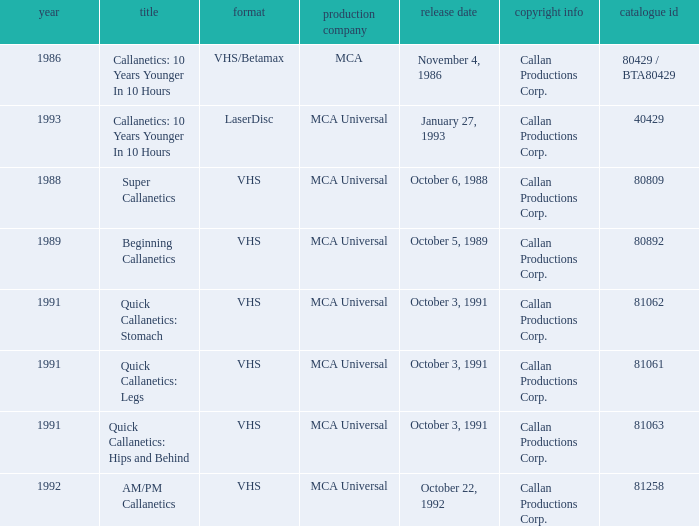Name the catalog number for am/pm callanetics 81258.0. Write the full table. {'header': ['year', 'title', 'format', 'production company', 'release date', 'copyright info', 'catalogue id'], 'rows': [['1986', 'Callanetics: 10 Years Younger In 10 Hours', 'VHS/Betamax', 'MCA', 'November 4, 1986', 'Callan Productions Corp.', '80429 / BTA80429'], ['1993', 'Callanetics: 10 Years Younger In 10 Hours', 'LaserDisc', 'MCA Universal', 'January 27, 1993', 'Callan Productions Corp.', '40429'], ['1988', 'Super Callanetics', 'VHS', 'MCA Universal', 'October 6, 1988', 'Callan Productions Corp.', '80809'], ['1989', 'Beginning Callanetics', 'VHS', 'MCA Universal', 'October 5, 1989', 'Callan Productions Corp.', '80892'], ['1991', 'Quick Callanetics: Stomach', 'VHS', 'MCA Universal', 'October 3, 1991', 'Callan Productions Corp.', '81062'], ['1991', 'Quick Callanetics: Legs', 'VHS', 'MCA Universal', 'October 3, 1991', 'Callan Productions Corp.', '81061'], ['1991', 'Quick Callanetics: Hips and Behind', 'VHS', 'MCA Universal', 'October 3, 1991', 'Callan Productions Corp.', '81063'], ['1992', 'AM/PM Callanetics', 'VHS', 'MCA Universal', 'October 22, 1992', 'Callan Productions Corp.', '81258']]} 